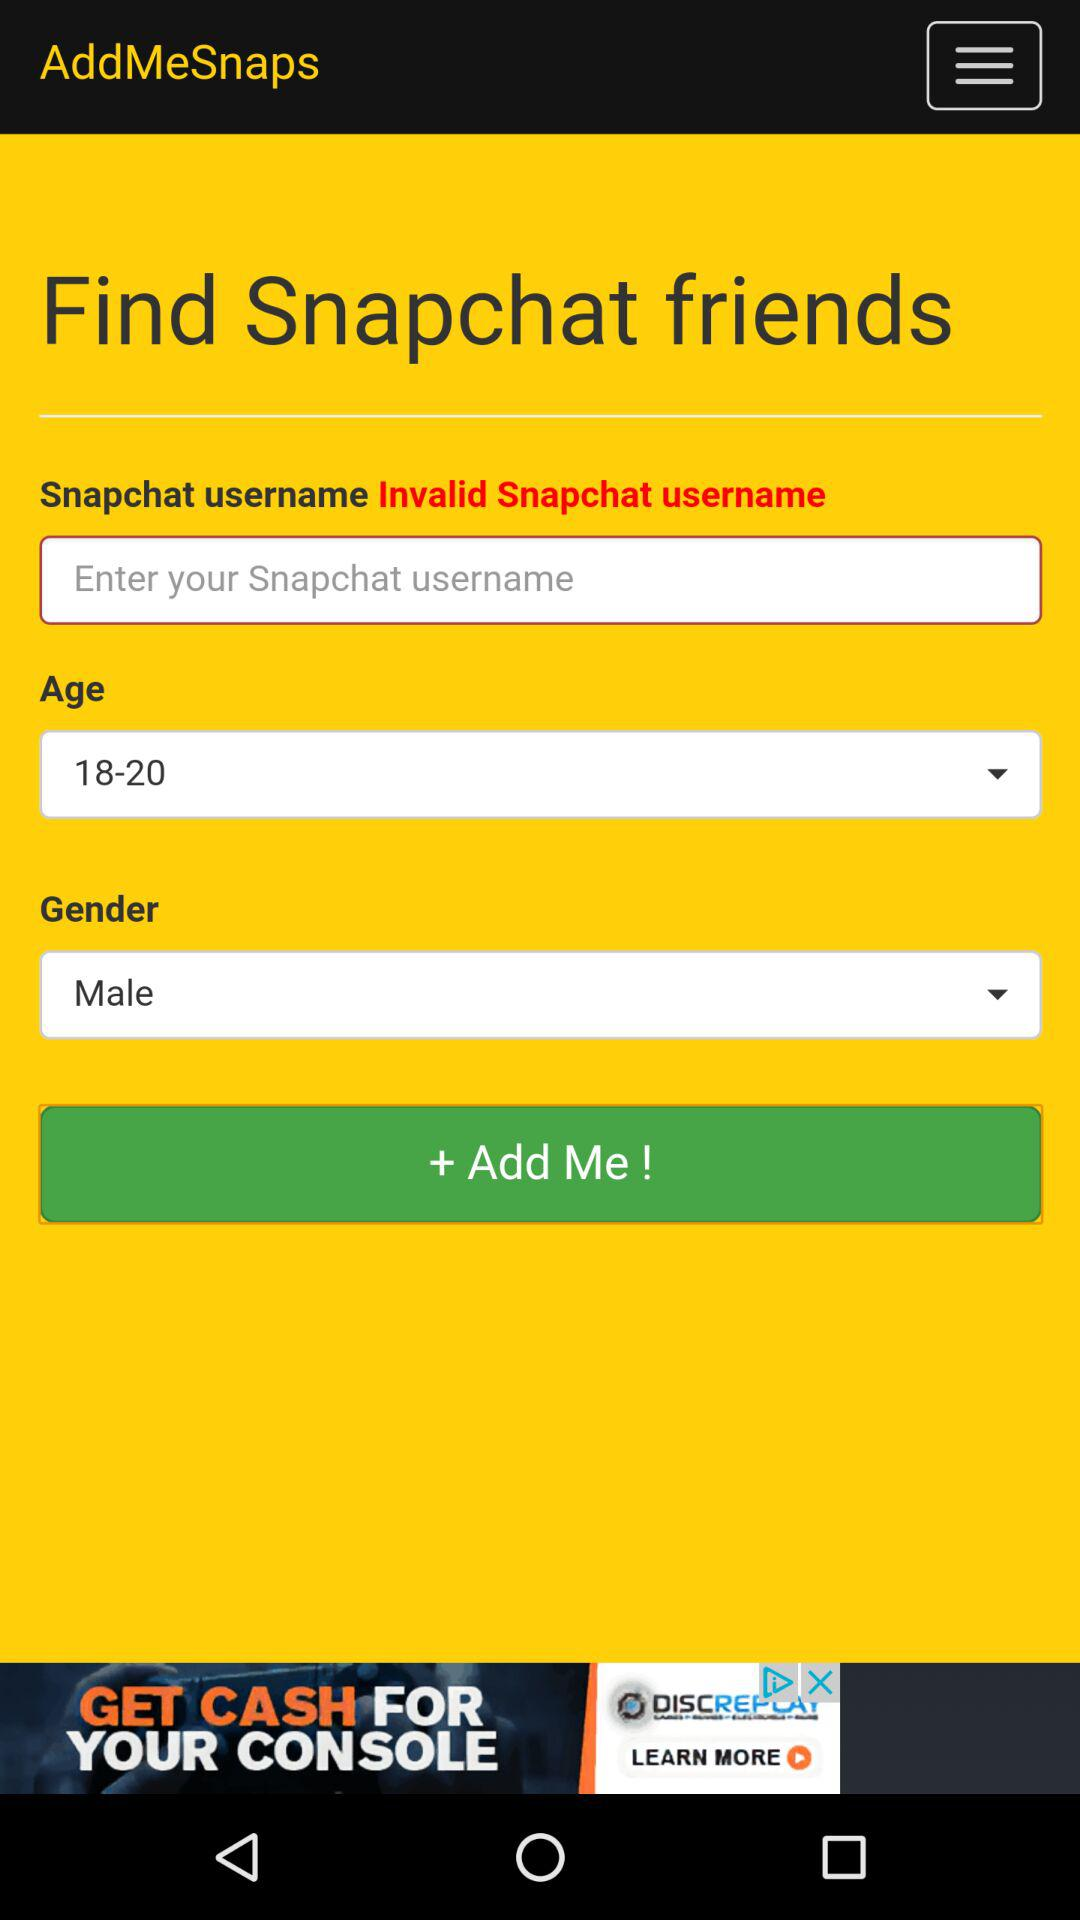What is the name of the application? The name of the application is "AddMeSnaps". 